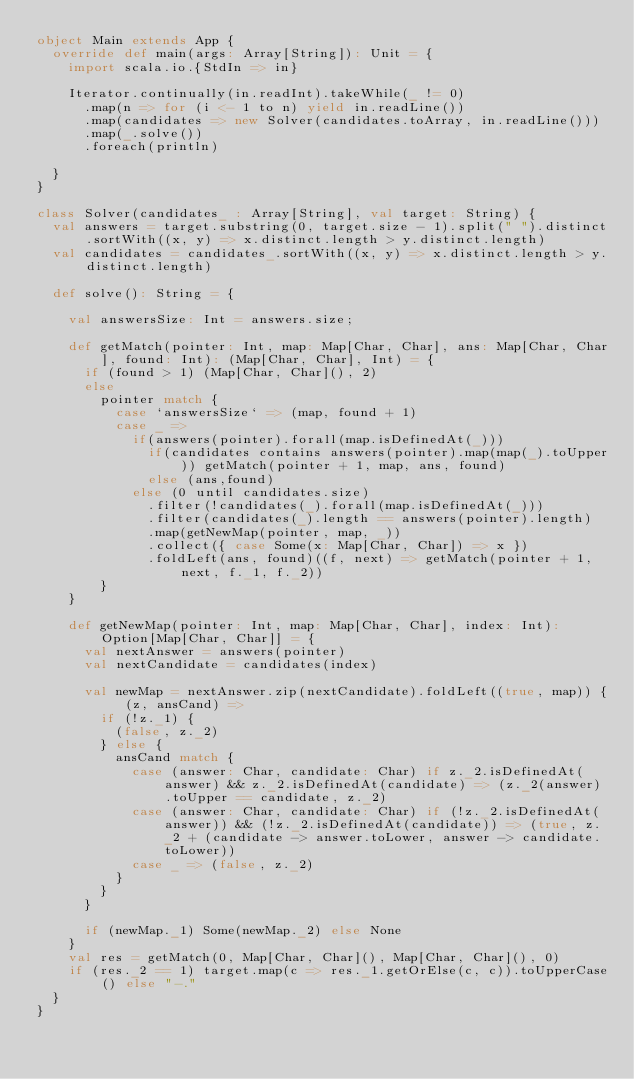Convert code to text. <code><loc_0><loc_0><loc_500><loc_500><_Scala_>object Main extends App {
  override def main(args: Array[String]): Unit = {
    import scala.io.{StdIn => in}

    Iterator.continually(in.readInt).takeWhile(_ != 0)
      .map(n => for (i <- 1 to n) yield in.readLine())
      .map(candidates => new Solver(candidates.toArray, in.readLine()))
      .map(_.solve())
      .foreach(println)

  }
}

class Solver(candidates_ : Array[String], val target: String) {
  val answers = target.substring(0, target.size - 1).split(" ").distinct.sortWith((x, y) => x.distinct.length > y.distinct.length)
  val candidates = candidates_.sortWith((x, y) => x.distinct.length > y.distinct.length)

  def solve(): String = {

    val answersSize: Int = answers.size;

    def getMatch(pointer: Int, map: Map[Char, Char], ans: Map[Char, Char], found: Int): (Map[Char, Char], Int) = {
      if (found > 1) (Map[Char, Char](), 2)
      else
        pointer match {
          case `answersSize` => (map, found + 1)
          case _ =>
            if(answers(pointer).forall(map.isDefinedAt(_)))
              if(candidates contains answers(pointer).map(map(_).toUpper)) getMatch(pointer + 1, map, ans, found)
              else (ans,found)
            else (0 until candidates.size)
              .filter(!candidates(_).forall(map.isDefinedAt(_)))
              .filter(candidates(_).length == answers(pointer).length)
              .map(getNewMap(pointer, map, _))
              .collect({ case Some(x: Map[Char, Char]) => x })
              .foldLeft(ans, found)((f, next) => getMatch(pointer + 1, next, f._1, f._2))
        }
    }

    def getNewMap(pointer: Int, map: Map[Char, Char], index: Int): Option[Map[Char, Char]] = {
      val nextAnswer = answers(pointer)
      val nextCandidate = candidates(index)

      val newMap = nextAnswer.zip(nextCandidate).foldLeft((true, map)) { (z, ansCand) =>
        if (!z._1) {
          (false, z._2)
        } else {
          ansCand match {
            case (answer: Char, candidate: Char) if z._2.isDefinedAt(answer) && z._2.isDefinedAt(candidate) => (z._2(answer).toUpper == candidate, z._2)
            case (answer: Char, candidate: Char) if (!z._2.isDefinedAt(answer)) && (!z._2.isDefinedAt(candidate)) => (true, z._2 + (candidate -> answer.toLower, answer -> candidate.toLower))
            case _ => (false, z._2)
          }
        }
      }

      if (newMap._1) Some(newMap._2) else None
    }
    val res = getMatch(0, Map[Char, Char](), Map[Char, Char](), 0)
    if (res._2 == 1) target.map(c => res._1.getOrElse(c, c)).toUpperCase() else "-."
  }
}</code> 